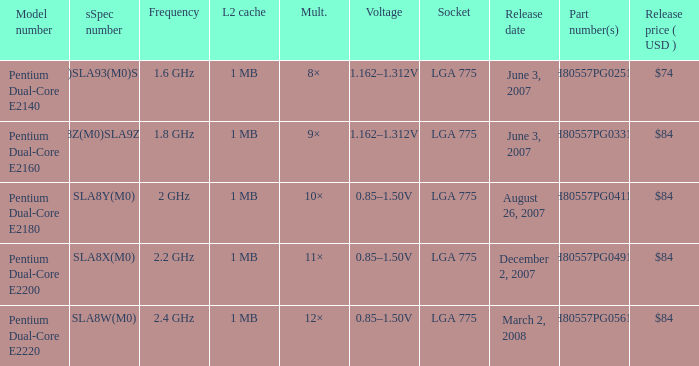Which component numbers have a 2.4 ghz frequency? HH80557PG0561M. 